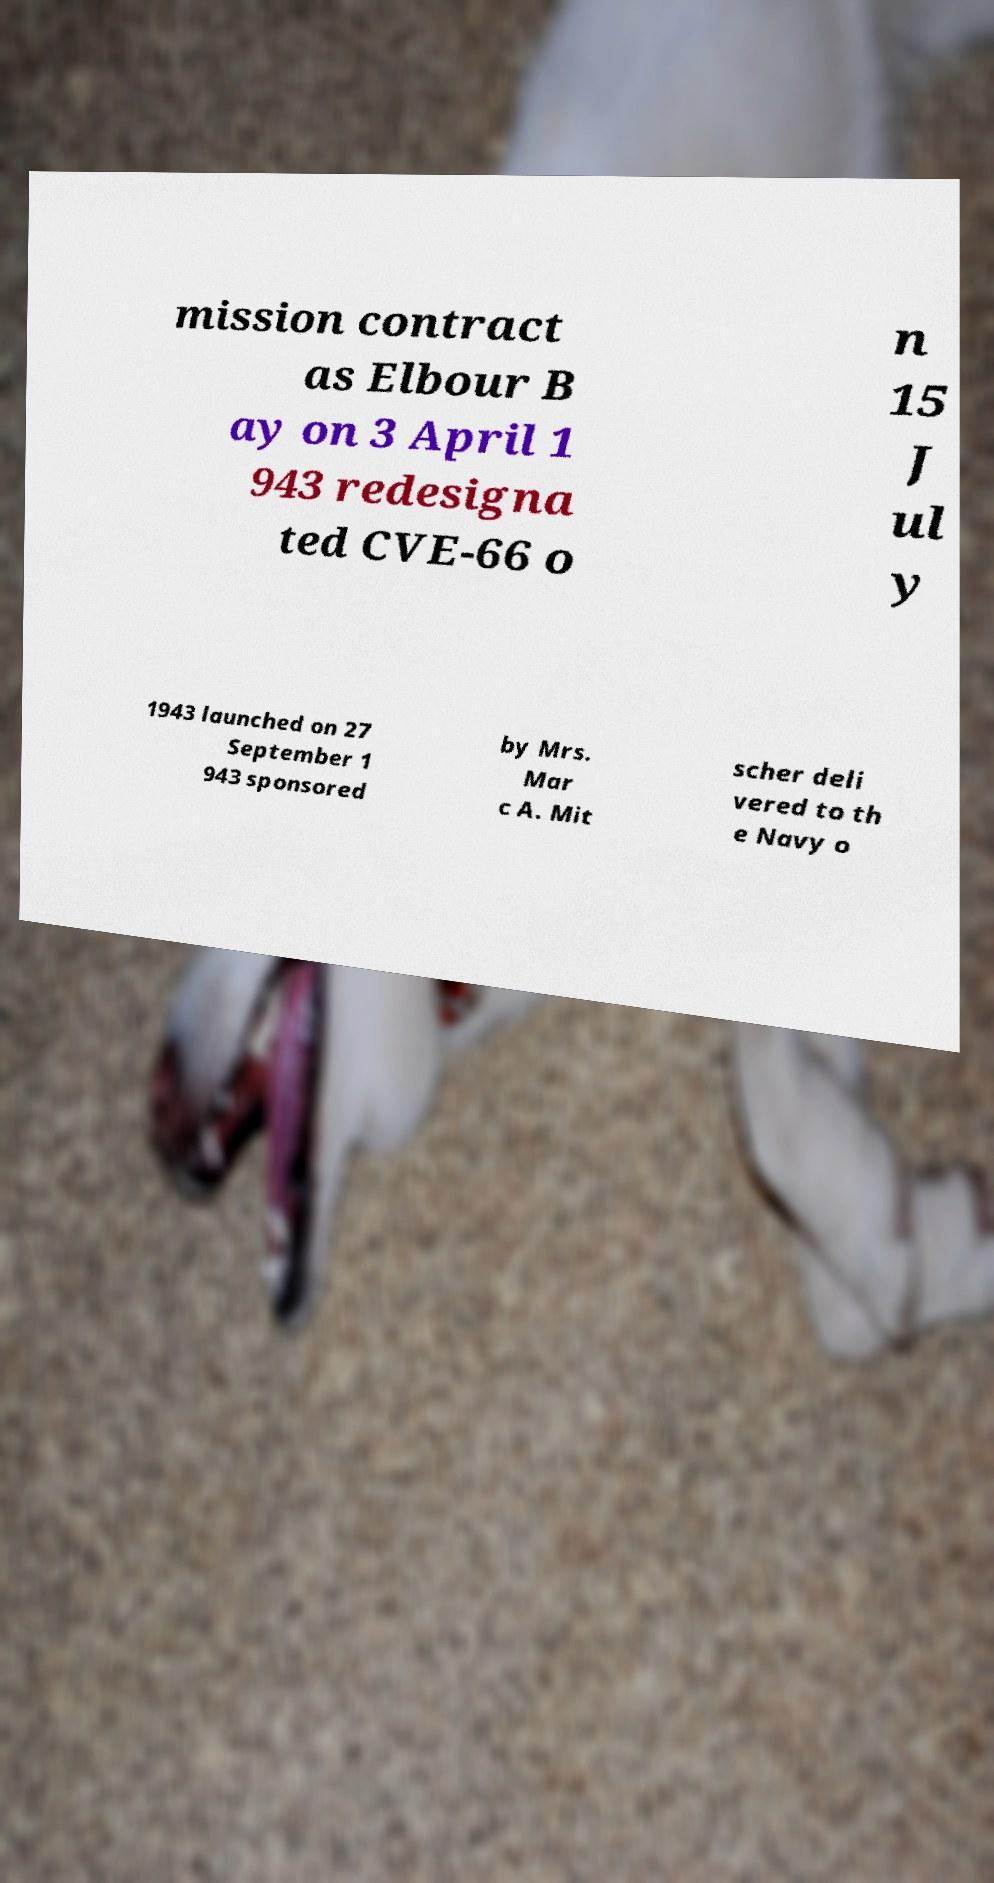For documentation purposes, I need the text within this image transcribed. Could you provide that? mission contract as Elbour B ay on 3 April 1 943 redesigna ted CVE-66 o n 15 J ul y 1943 launched on 27 September 1 943 sponsored by Mrs. Mar c A. Mit scher deli vered to th e Navy o 